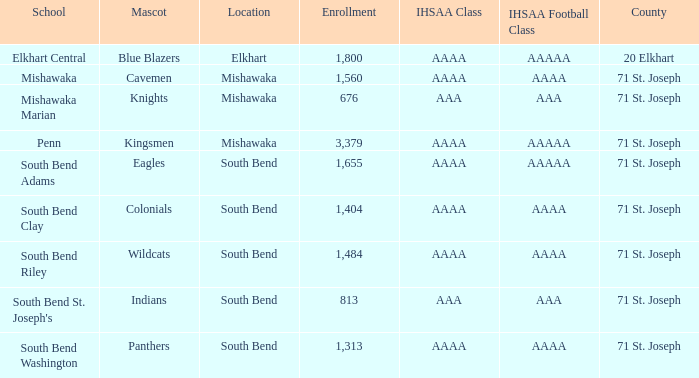Could you parse the entire table? {'header': ['School', 'Mascot', 'Location', 'Enrollment', 'IHSAA Class', 'IHSAA Football Class', 'County'], 'rows': [['Elkhart Central', 'Blue Blazers', 'Elkhart', '1,800', 'AAAA', 'AAAAA', '20 Elkhart'], ['Mishawaka', 'Cavemen', 'Mishawaka', '1,560', 'AAAA', 'AAAA', '71 St. Joseph'], ['Mishawaka Marian', 'Knights', 'Mishawaka', '676', 'AAA', 'AAA', '71 St. Joseph'], ['Penn', 'Kingsmen', 'Mishawaka', '3,379', 'AAAA', 'AAAAA', '71 St. Joseph'], ['South Bend Adams', 'Eagles', 'South Bend', '1,655', 'AAAA', 'AAAAA', '71 St. Joseph'], ['South Bend Clay', 'Colonials', 'South Bend', '1,404', 'AAAA', 'AAAA', '71 St. Joseph'], ['South Bend Riley', 'Wildcats', 'South Bend', '1,484', 'AAAA', 'AAAA', '71 St. Joseph'], ["South Bend St. Joseph's", 'Indians', 'South Bend', '813', 'AAA', 'AAA', '71 St. Joseph'], ['South Bend Washington', 'Panthers', 'South Bend', '1,313', 'AAAA', 'AAAA', '71 St. Joseph']]} What venue has kingsmen as the emblem? Mishawaka. 